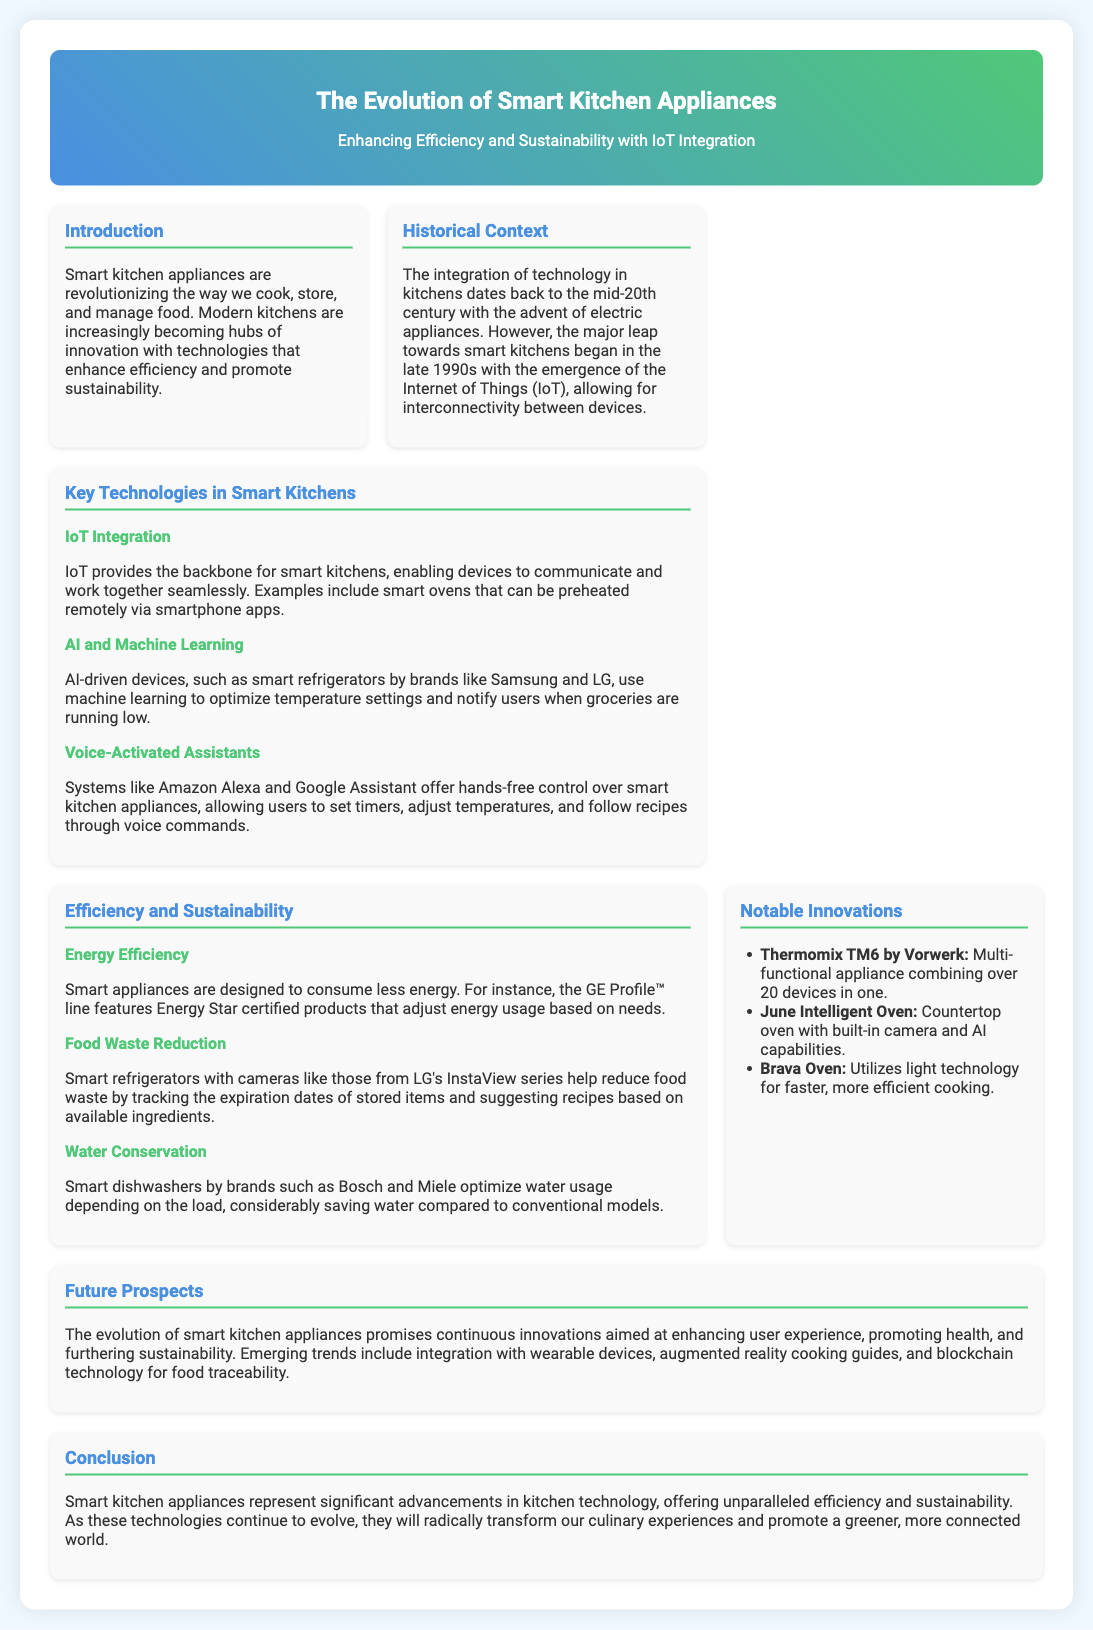What is the main focus of the poster? The main focus is on the evolution of smart kitchen appliances in the context of efficiency and sustainability with IoT integration.
Answer: The Evolution of Smart Kitchen Appliances When did the major leap towards smart kitchens begin? The document mentions that this leap began in the late 1990s with the emergence of the Internet of Things (IoT).
Answer: Late 1990s Which technology optimizes temperature settings in smart refrigerators? The smart refrigerators use AI and machine learning to optimize their temperature settings.
Answer: AI and Machine Learning What are smart dishwashers designed to do? They optimize water usage depending on the load, thereby saving water compared to conventional models.
Answer: Optimize water usage What notable innovation combines over 20 appliances in one? The Thermomix TM6 by Vorwerk is noted for combining over 20 devices in one.
Answer: Thermomix TM6 by Vorwerk How do smart appliances contribute to food waste reduction? They track expiration dates of stored items and suggest recipes based on available ingredients.
Answer: Track expiration dates What is a future prospect mentioned for smart kitchen appliances? Integration with wearable devices is listed as a future prospect for smart kitchen appliances.
Answer: Integration with wearable devices What is the color theme of the header section? The header section features a gradient background with blue and green hues.
Answer: Gradient blue and green 